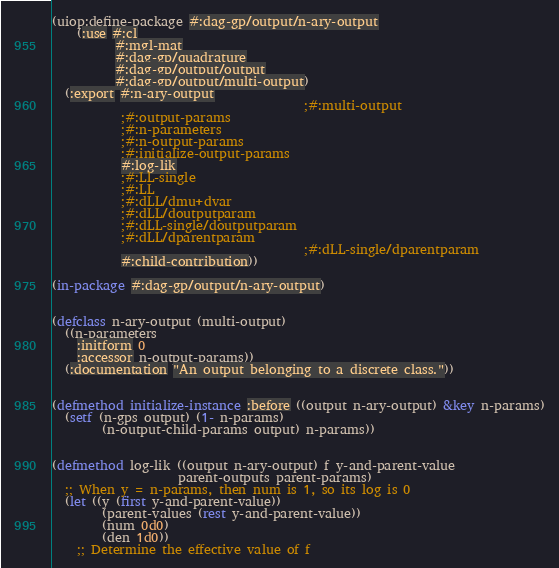Convert code to text. <code><loc_0><loc_0><loc_500><loc_500><_Lisp_>(uiop:define-package #:dag-gp/output/n-ary-output
    (:use #:cl
          #:mgl-mat
          #:dag-gp/quadrature
          #:dag-gp/output/output
          #:dag-gp/output/multi-output)
  (:export #:n-ary-output
                                        ;#:multi-output
           ;#:output-params
           ;#:n-parameters
           ;#:n-output-params
           ;#:initialize-output-params
           #:log-lik
           ;#:LL-single
           ;#:LL
           ;#:dLL/dmu+dvar
           ;#:dLL/doutputparam
           ;#:dLL-single/doutputparam
           ;#:dLL/dparentparam
                                        ;#:dLL-single/dparentparam
           #:child-contribution))

(in-package #:dag-gp/output/n-ary-output)


(defclass n-ary-output (multi-output)
  ((n-parameters
    :initform 0
    :accessor n-output-params))
  (:documentation "An output belonging to a discrete class."))


(defmethod initialize-instance :before ((output n-ary-output) &key n-params)
  (setf (n-gps output) (1- n-params)
        (n-output-child-params output) n-params))


(defmethod log-lik ((output n-ary-output) f y-and-parent-value
                    parent-outputs parent-params)
  ;; When y = n-params, then num is 1, so its log is 0
  (let ((y (first y-and-parent-value))
        (parent-values (rest y-and-parent-value))
        (num 0d0)
        (den 1d0))
    ;; Determine the effective value of f</code> 